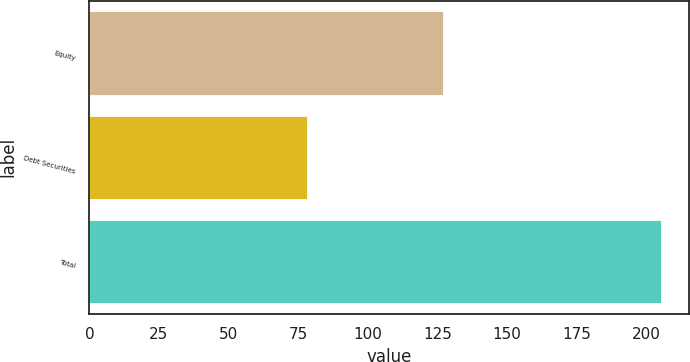Convert chart to OTSL. <chart><loc_0><loc_0><loc_500><loc_500><bar_chart><fcel>Equity<fcel>Debt Securities<fcel>Total<nl><fcel>127<fcel>78.1<fcel>205.1<nl></chart> 